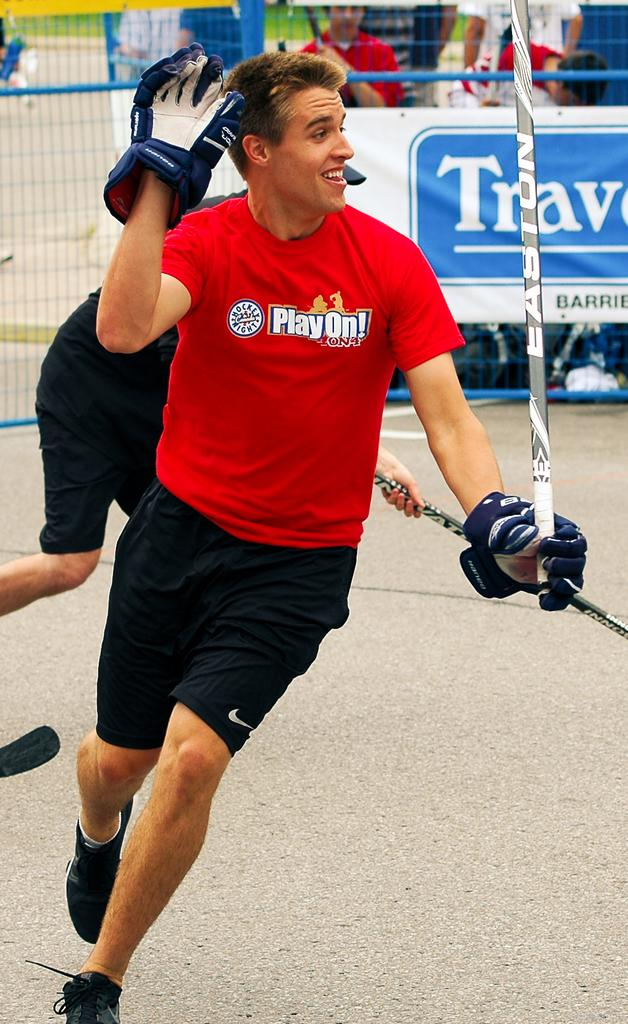Who is the main subject in the image? There is a man in the image. What is the man doing in the image? The man is on the ground and holding a stick. What is the man wearing in the image? The man is wearing gloves. What can be seen in the background of the image? There are people, a fence, a banner, and other objects visible in the background of the image. How does the man use the brake while holding the stick in the image? There is no brake present in the image, as the man is holding a stick and not a vehicle with brakes. 